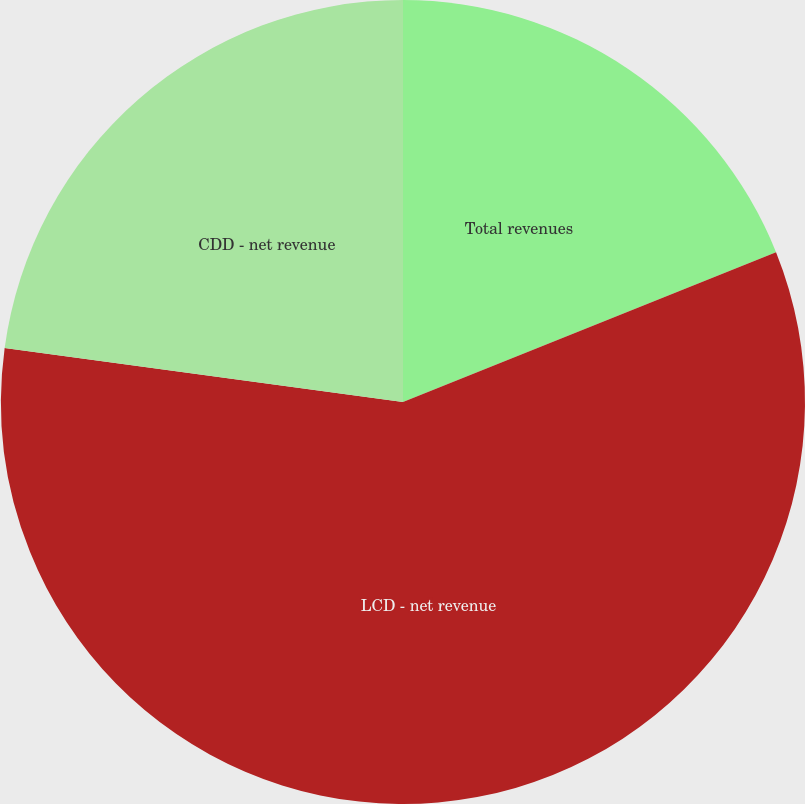Convert chart to OTSL. <chart><loc_0><loc_0><loc_500><loc_500><pie_chart><fcel>Total revenues<fcel>LCD - net revenue<fcel>CDD - net revenue<nl><fcel>18.92%<fcel>58.22%<fcel>22.85%<nl></chart> 